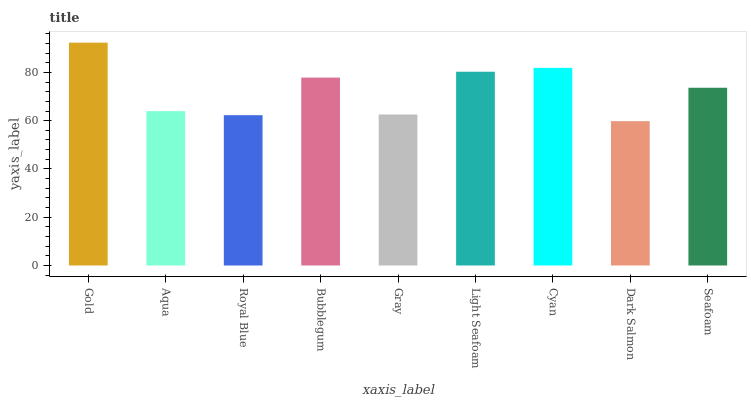Is Aqua the minimum?
Answer yes or no. No. Is Aqua the maximum?
Answer yes or no. No. Is Gold greater than Aqua?
Answer yes or no. Yes. Is Aqua less than Gold?
Answer yes or no. Yes. Is Aqua greater than Gold?
Answer yes or no. No. Is Gold less than Aqua?
Answer yes or no. No. Is Seafoam the high median?
Answer yes or no. Yes. Is Seafoam the low median?
Answer yes or no. Yes. Is Gray the high median?
Answer yes or no. No. Is Gold the low median?
Answer yes or no. No. 